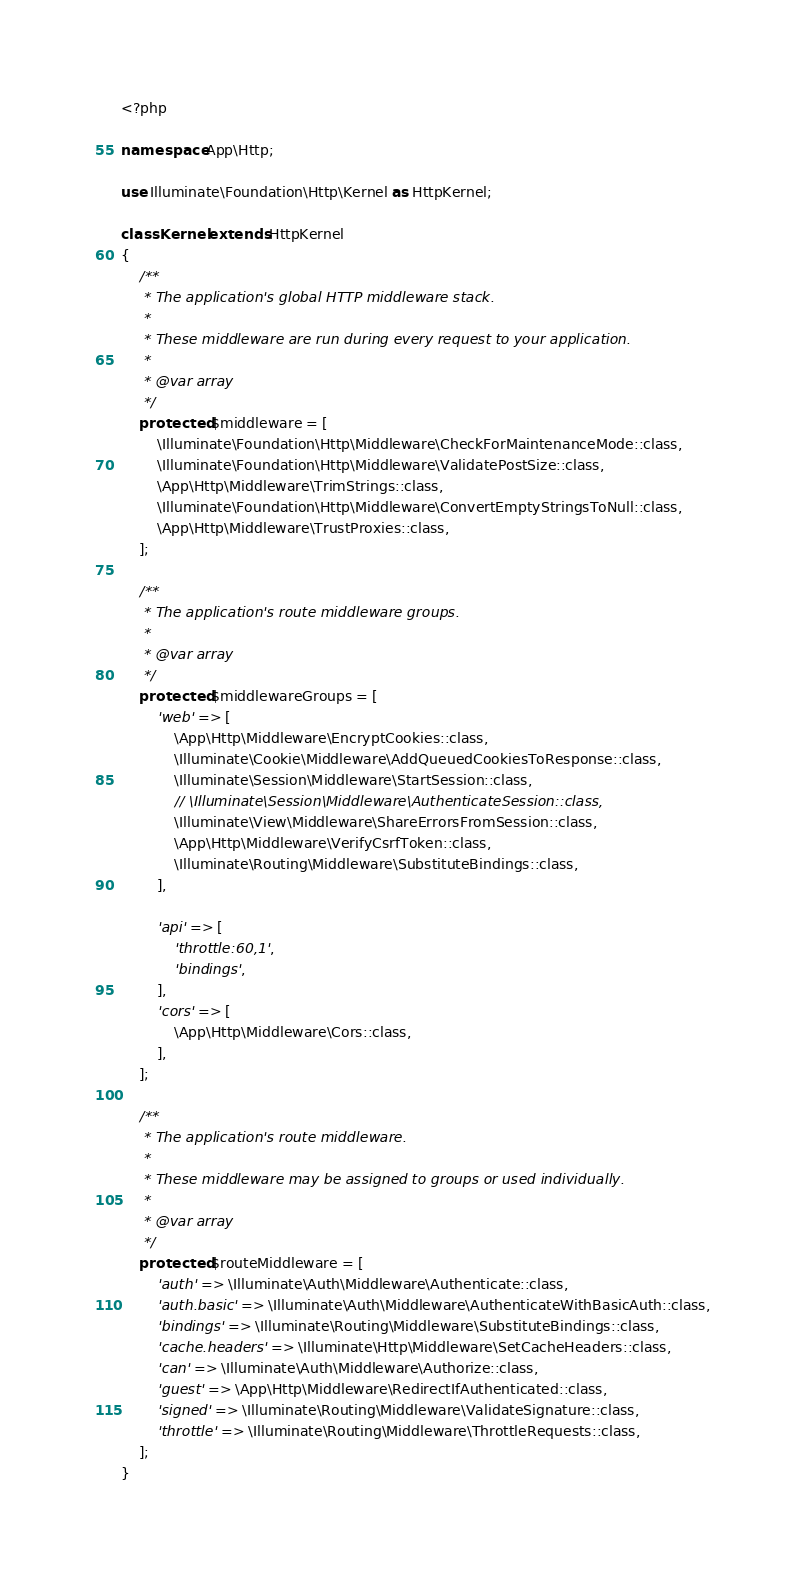Convert code to text. <code><loc_0><loc_0><loc_500><loc_500><_PHP_><?php

namespace App\Http;

use Illuminate\Foundation\Http\Kernel as HttpKernel;

class Kernel extends HttpKernel
{
    /**
     * The application's global HTTP middleware stack.
     *
     * These middleware are run during every request to your application.
     *
     * @var array
     */
    protected $middleware = [
        \Illuminate\Foundation\Http\Middleware\CheckForMaintenanceMode::class,
        \Illuminate\Foundation\Http\Middleware\ValidatePostSize::class,
        \App\Http\Middleware\TrimStrings::class,
        \Illuminate\Foundation\Http\Middleware\ConvertEmptyStringsToNull::class,
        \App\Http\Middleware\TrustProxies::class,
    ];

    /**
     * The application's route middleware groups.
     *
     * @var array
     */
    protected $middlewareGroups = [
        'web' => [
            \App\Http\Middleware\EncryptCookies::class,
            \Illuminate\Cookie\Middleware\AddQueuedCookiesToResponse::class,
            \Illuminate\Session\Middleware\StartSession::class,
            // \Illuminate\Session\Middleware\AuthenticateSession::class,
            \Illuminate\View\Middleware\ShareErrorsFromSession::class,
            \App\Http\Middleware\VerifyCsrfToken::class,
            \Illuminate\Routing\Middleware\SubstituteBindings::class,
        ],

        'api' => [
            'throttle:60,1',
            'bindings',
        ],
        'cors' => [
            \App\Http\Middleware\Cors::class,
        ],
    ];

    /**
     * The application's route middleware.
     *
     * These middleware may be assigned to groups or used individually.
     *
     * @var array
     */
    protected $routeMiddleware = [
        'auth' => \Illuminate\Auth\Middleware\Authenticate::class,
        'auth.basic' => \Illuminate\Auth\Middleware\AuthenticateWithBasicAuth::class,
        'bindings' => \Illuminate\Routing\Middleware\SubstituteBindings::class,
        'cache.headers' => \Illuminate\Http\Middleware\SetCacheHeaders::class,
        'can' => \Illuminate\Auth\Middleware\Authorize::class,
        'guest' => \App\Http\Middleware\RedirectIfAuthenticated::class,
        'signed' => \Illuminate\Routing\Middleware\ValidateSignature::class,
        'throttle' => \Illuminate\Routing\Middleware\ThrottleRequests::class,
    ];
}
</code> 